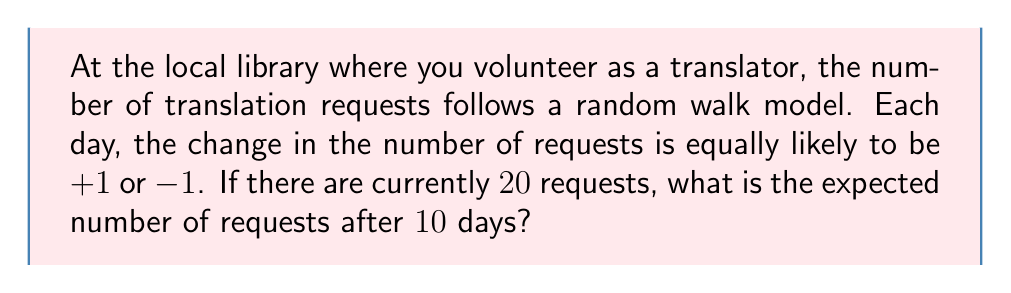What is the answer to this math problem? Let's approach this step-by-step:

1) In a random walk model, the expected change at each step is:

   $$E[\Delta X] = (+1) \cdot P(+1) + (-1) \cdot P(-1) = 1 \cdot 0.5 + (-1) \cdot 0.5 = 0$$

2) This means that on average, we expect no change in the number of requests each day.

3) The expected value after n steps in a random walk is:

   $$E[X_n] = X_0 + n \cdot E[\Delta X]$$

   Where $X_0$ is the initial value and n is the number of steps.

4) In this case:
   - $X_0 = 20$ (initial number of requests)
   - $n = 10$ (number of days)
   - $E[\Delta X] = 0$ (as calculated in step 1)

5) Plugging these values into the formula:

   $$E[X_{10}] = 20 + 10 \cdot 0 = 20$$

Therefore, the expected number of requests after 10 days is still 20.
Answer: 20 requests 